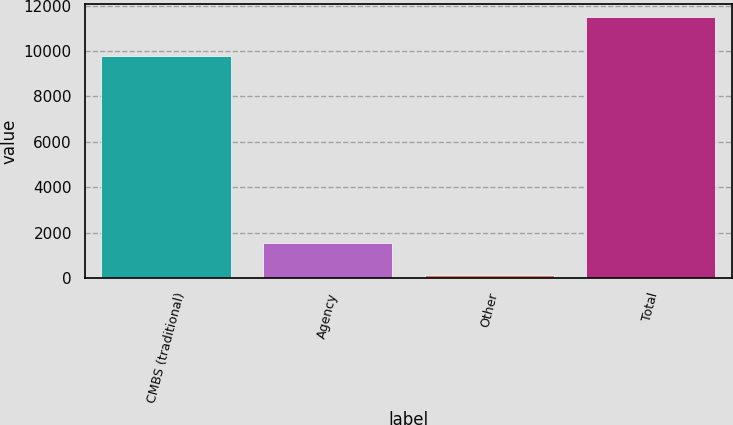<chart> <loc_0><loc_0><loc_500><loc_500><bar_chart><fcel>CMBS (traditional)<fcel>Agency<fcel>Other<fcel>Total<nl><fcel>9794<fcel>1558<fcel>130<fcel>11482<nl></chart> 